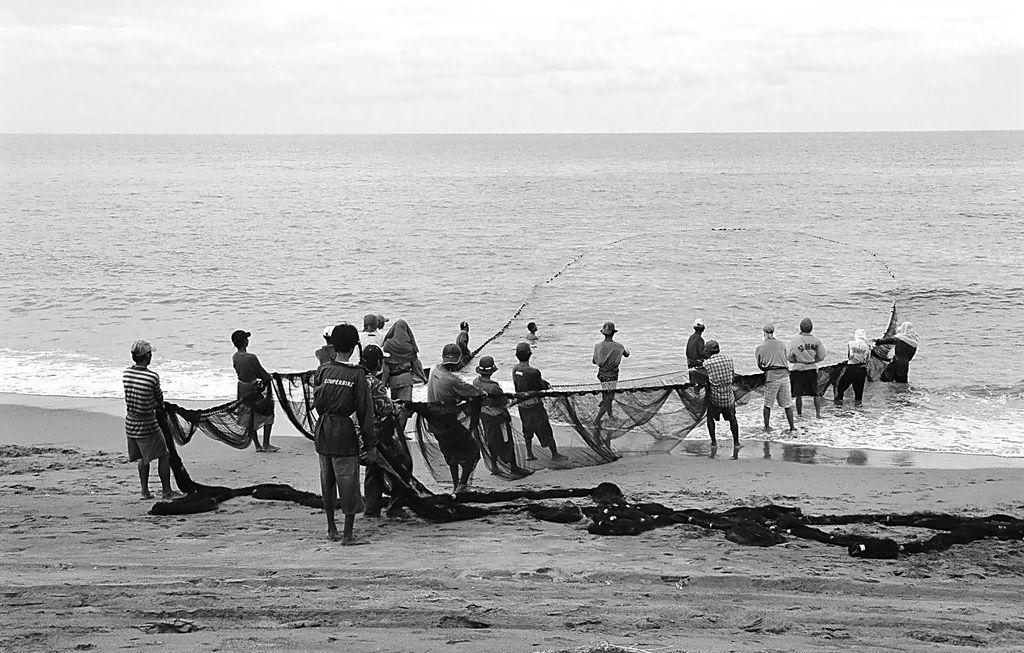Could you give a brief overview of what you see in this image? A group of people are carrying the net near the sea, at the top it is the cloudy sky. 